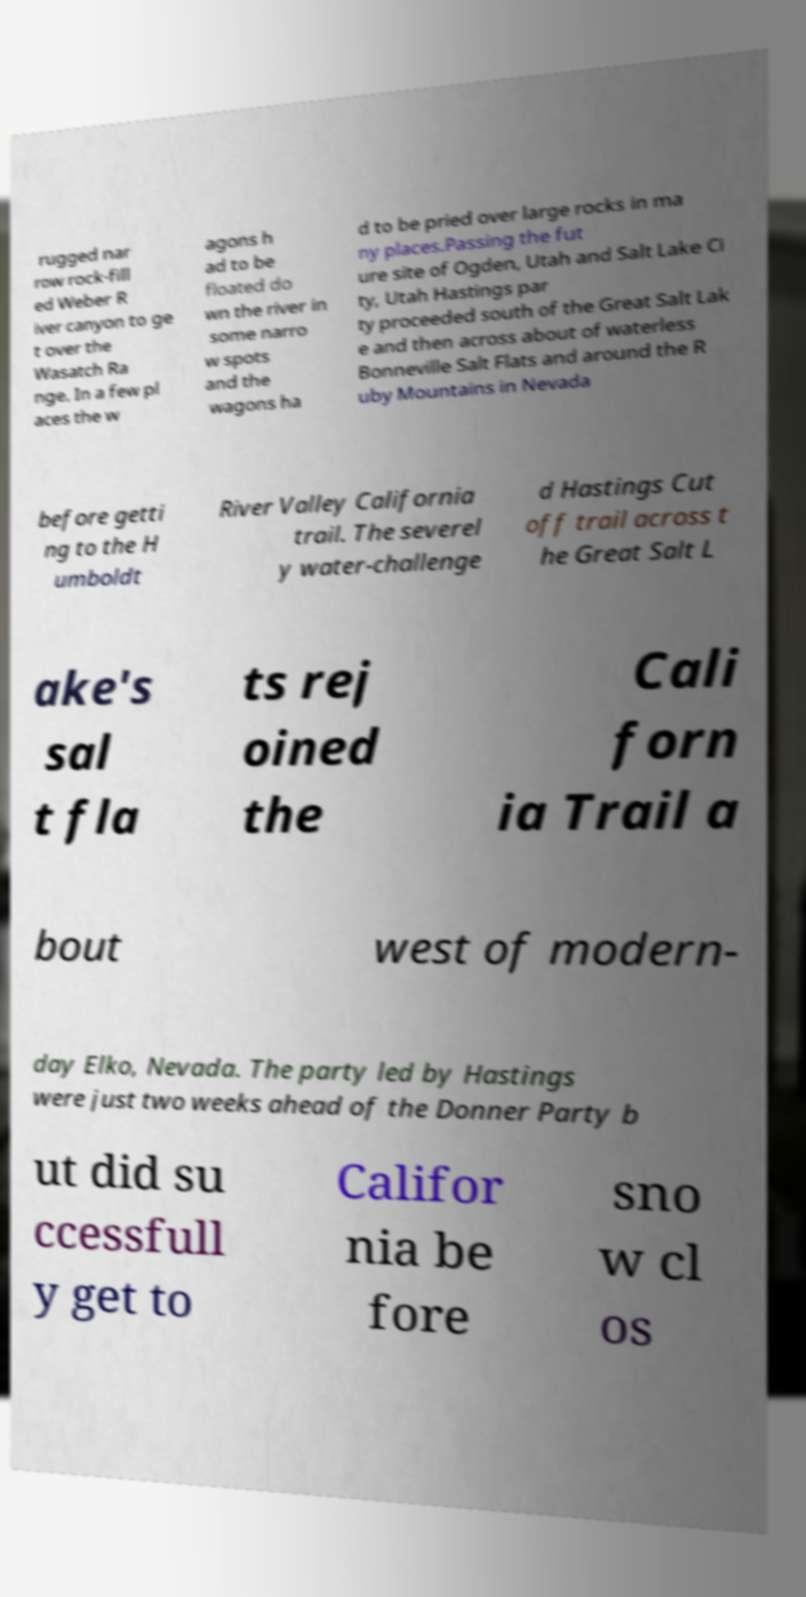I need the written content from this picture converted into text. Can you do that? rugged nar row rock-fill ed Weber R iver canyon to ge t over the Wasatch Ra nge. In a few pl aces the w agons h ad to be floated do wn the river in some narro w spots and the wagons ha d to be pried over large rocks in ma ny places.Passing the fut ure site of Ogden, Utah and Salt Lake Ci ty, Utah Hastings par ty proceeded south of the Great Salt Lak e and then across about of waterless Bonneville Salt Flats and around the R uby Mountains in Nevada before getti ng to the H umboldt River Valley California trail. The severel y water-challenge d Hastings Cut off trail across t he Great Salt L ake's sal t fla ts rej oined the Cali forn ia Trail a bout west of modern- day Elko, Nevada. The party led by Hastings were just two weeks ahead of the Donner Party b ut did su ccessfull y get to Califor nia be fore sno w cl os 